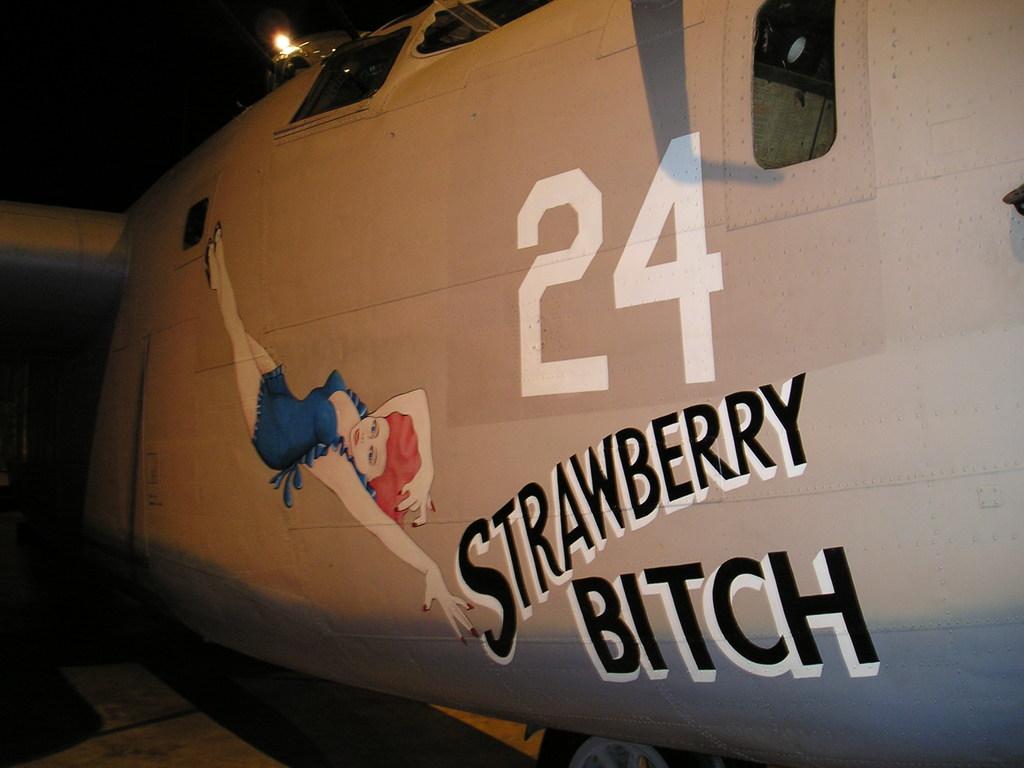What is the name of the plane?
Provide a succinct answer. Strawberry bitch. What is the name of the fruit on the plane?
Give a very brief answer. Strawberry. 